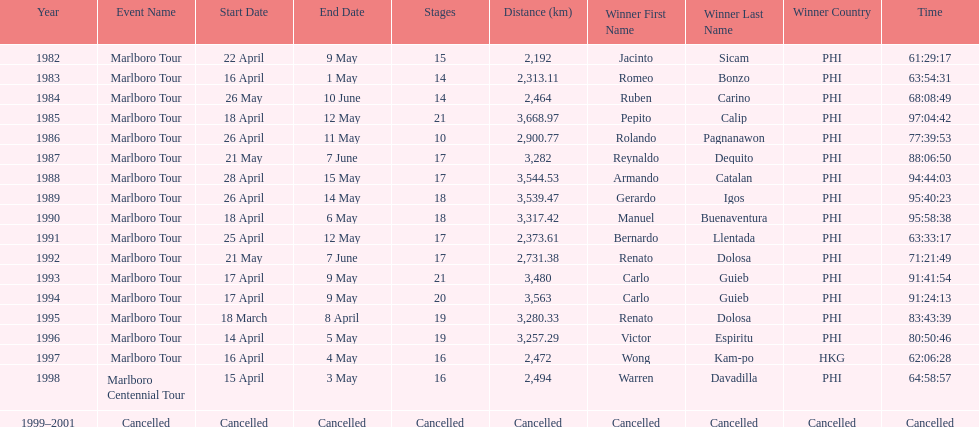What was the total number of winners before the tour was canceled? 17. 